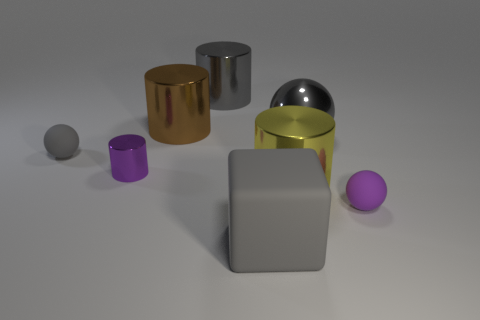What is the color of the big metallic thing that is in front of the gray ball on the left side of the large brown metal thing?
Give a very brief answer. Yellow. Is the number of gray shiny cylinders less than the number of small yellow blocks?
Ensure brevity in your answer.  No. What number of yellow things are the same shape as the big brown object?
Ensure brevity in your answer.  1. What is the color of the metallic sphere that is the same size as the yellow thing?
Your answer should be compact. Gray. Are there the same number of large gray matte things that are behind the purple cylinder and large gray things that are right of the large ball?
Give a very brief answer. Yes. Are there any gray balls that have the same size as the yellow cylinder?
Give a very brief answer. Yes. What size is the purple shiny thing?
Make the answer very short. Small. Is the number of big metal balls that are behind the gray shiny cylinder the same as the number of red objects?
Offer a very short reply. Yes. How many other things are the same color as the metallic ball?
Your response must be concise. 3. The large metallic thing that is behind the small purple cylinder and on the right side of the gray cube is what color?
Keep it short and to the point. Gray. 